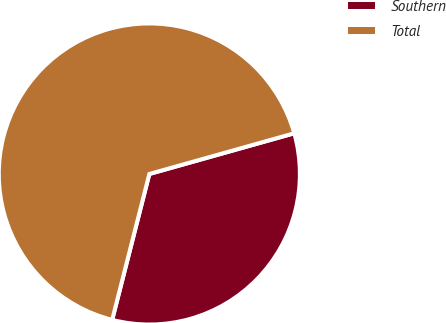<chart> <loc_0><loc_0><loc_500><loc_500><pie_chart><fcel>Southern<fcel>Total<nl><fcel>33.33%<fcel>66.67%<nl></chart> 